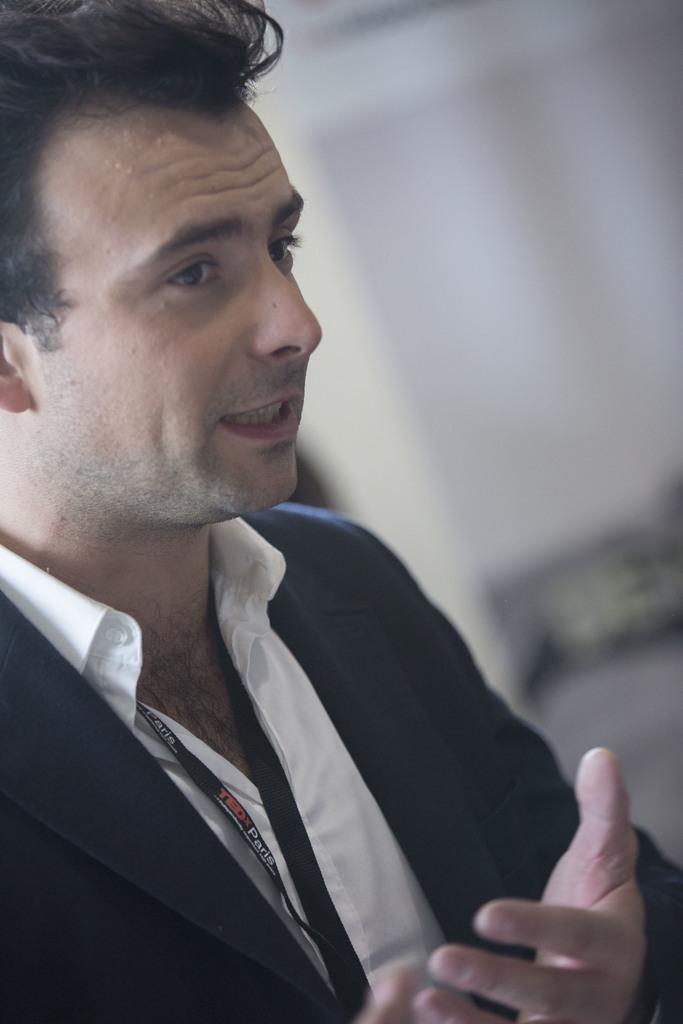Who is present in the image? There is a man in the image. What can be observed about the background of the image? The background of the image is blurred. What type of insurance policy does the man have in the image? There is no information about insurance policies in the image; it only features a man and a blurred background. 